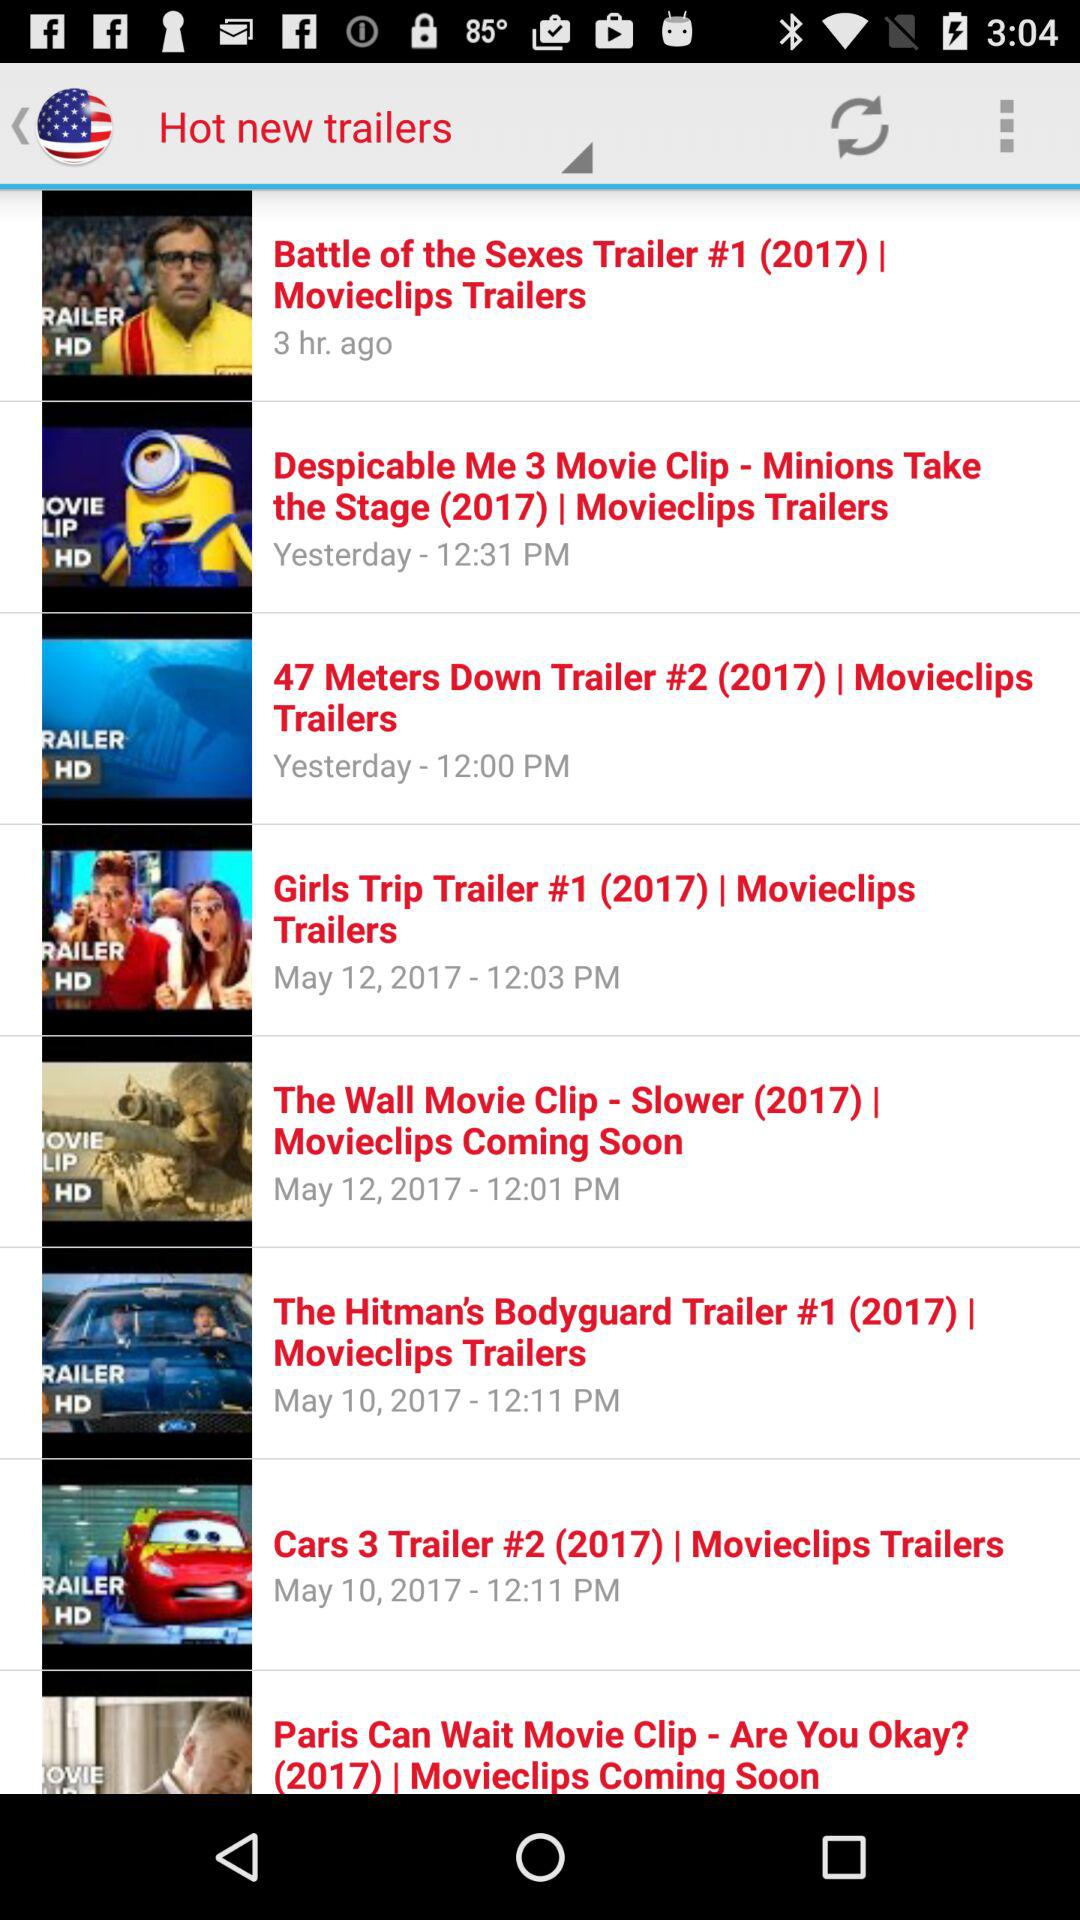How many hours ago was the "Battle of the Sexes" trailer released? The "Battle of the Sexes" trailer was released 3 hours ago. 